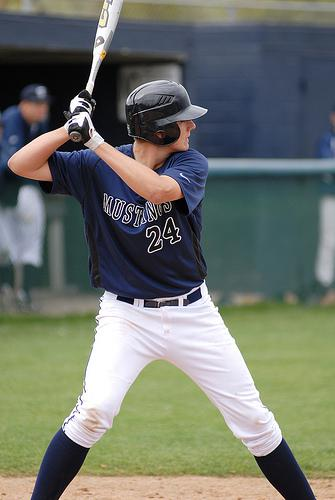Question: where was this photo taken?
Choices:
A. At the beach.
B. A tennis court.
C. Baseball field.
D. At the zoo.
Answer with the letter. Answer: C Question: what color is the bat?
Choices:
A. Brown.
B. Black.
C. Silver.
D. Gray.
Answer with the letter. Answer: C Question: what is the batter holding?
Choices:
A. A batting glove.
B. A bat.
C. A hat.
D. A helmet.
Answer with the letter. Answer: B Question: who is up at bat?
Choices:
A. Number 34.
B. Number 1.
C. Number 6.
D. Number 24.
Answer with the letter. Answer: D Question: how many people can be clearly seen?
Choices:
A. Three.
B. Four.
C. One.
D. Two.
Answer with the letter. Answer: D 